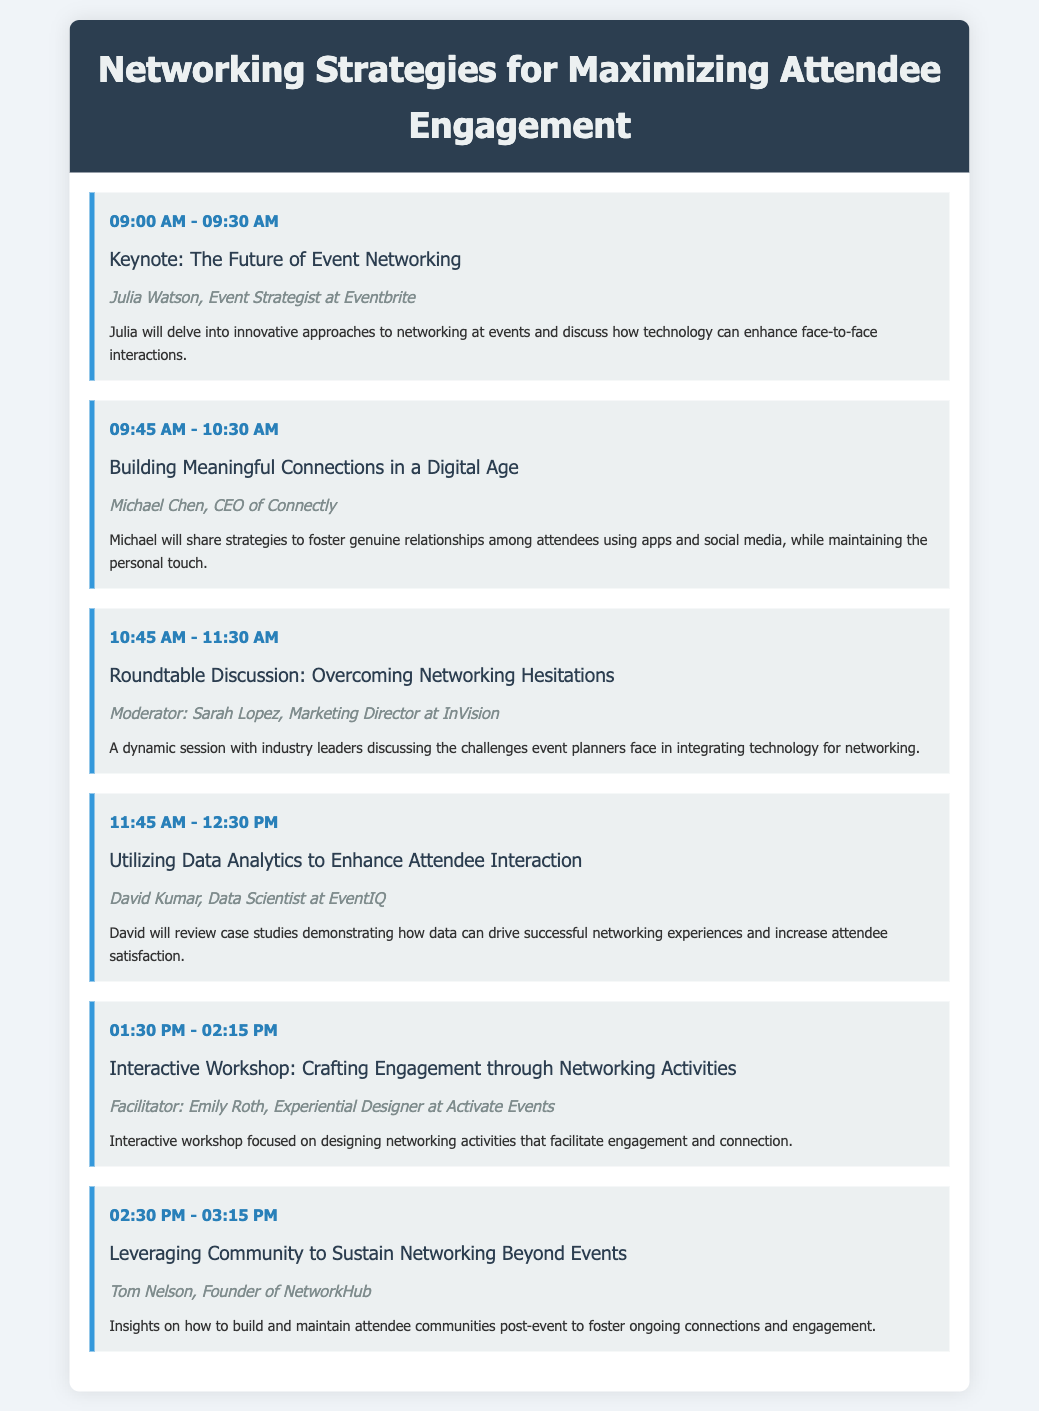What time does the keynote session start? The keynote session, "The Future of Event Networking," starts at 09:00 AM.
Answer: 09:00 AM Who is the speaker for the session on building connections? Michael Chen, CEO of Connectly, is the speaker for that session.
Answer: Michael Chen What is the title of the roundtable discussion? The title of the roundtable discussion is "Overcoming Networking Hesitations."
Answer: Overcoming Networking Hesitations How long is the session on utilizing data analytics? The session lasts for 45 minutes, from 11:45 AM to 12:30 PM.
Answer: 45 minutes Who moderates the roundtable discussion? Sarah Lopez is the moderator for the roundtable discussion.
Answer: Sarah Lopez What is the focus of the interactive workshop? The workshop focuses on crafting engagement through networking activities.
Answer: Crafting engagement through networking activities What is the main topic of Tom Nelson's session? Tom Nelson's session focuses on leveraging community to sustain networking beyond events.
Answer: Leveraging community to sustain networking beyond events How many total sessions are included in the agenda? There are six sessions included in the agenda.
Answer: Six sessions What is the profession of David Kumar? David Kumar is a Data Scientist at EventIQ.
Answer: Data Scientist 